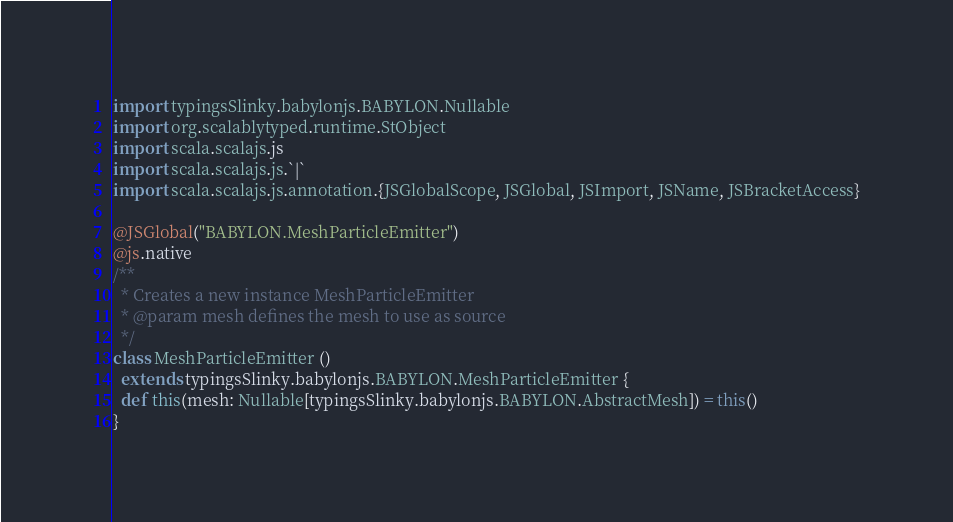<code> <loc_0><loc_0><loc_500><loc_500><_Scala_>import typingsSlinky.babylonjs.BABYLON.Nullable
import org.scalablytyped.runtime.StObject
import scala.scalajs.js
import scala.scalajs.js.`|`
import scala.scalajs.js.annotation.{JSGlobalScope, JSGlobal, JSImport, JSName, JSBracketAccess}

@JSGlobal("BABYLON.MeshParticleEmitter")
@js.native
/**
  * Creates a new instance MeshParticleEmitter
  * @param mesh defines the mesh to use as source
  */
class MeshParticleEmitter ()
  extends typingsSlinky.babylonjs.BABYLON.MeshParticleEmitter {
  def this(mesh: Nullable[typingsSlinky.babylonjs.BABYLON.AbstractMesh]) = this()
}
</code> 